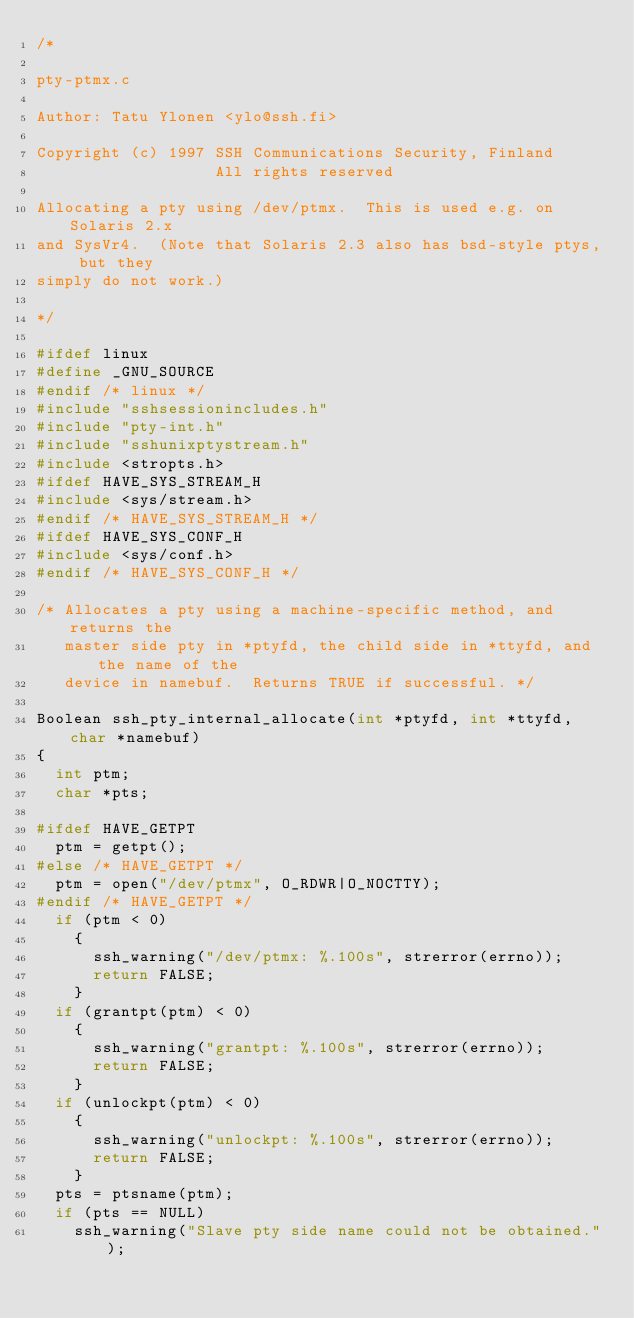<code> <loc_0><loc_0><loc_500><loc_500><_C_>/*

pty-ptmx.c

Author: Tatu Ylonen <ylo@ssh.fi>

Copyright (c) 1997 SSH Communications Security, Finland
                   All rights reserved

Allocating a pty using /dev/ptmx.  This is used e.g. on Solaris 2.x
and SysVr4.  (Note that Solaris 2.3 also has bsd-style ptys, but they
simply do not work.)

*/

#ifdef linux
#define _GNU_SOURCE
#endif /* linux */
#include "sshsessionincludes.h"
#include "pty-int.h"
#include "sshunixptystream.h"
#include <stropts.h>
#ifdef HAVE_SYS_STREAM_H
#include <sys/stream.h>
#endif /* HAVE_SYS_STREAM_H */
#ifdef HAVE_SYS_CONF_H
#include <sys/conf.h>
#endif /* HAVE_SYS_CONF_H */

/* Allocates a pty using a machine-specific method, and returns the
   master side pty in *ptyfd, the child side in *ttyfd, and the name of the
   device in namebuf.  Returns TRUE if successful. */

Boolean ssh_pty_internal_allocate(int *ptyfd, int *ttyfd, char *namebuf)
{
  int ptm;
  char *pts;

#ifdef HAVE_GETPT
  ptm = getpt();
#else /* HAVE_GETPT */
  ptm = open("/dev/ptmx", O_RDWR|O_NOCTTY);
#endif /* HAVE_GETPT */
  if (ptm < 0)
    {
      ssh_warning("/dev/ptmx: %.100s", strerror(errno));
      return FALSE;
    }
  if (grantpt(ptm) < 0)
    {
      ssh_warning("grantpt: %.100s", strerror(errno));
      return FALSE;
    }
  if (unlockpt(ptm) < 0)
    {
      ssh_warning("unlockpt: %.100s", strerror(errno));
      return FALSE;
    }
  pts = ptsname(ptm);
  if (pts == NULL)
    ssh_warning("Slave pty side name could not be obtained.");</code> 